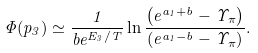Convert formula to latex. <formula><loc_0><loc_0><loc_500><loc_500>\Phi ( p _ { 3 } ) \simeq \frac { 1 } { b e ^ { E _ { 3 } / T } } \ln \frac { \left ( e ^ { a _ { 1 } + b } - \Upsilon _ { \pi } \right ) } { \left ( e ^ { a _ { 1 } - b } - \Upsilon _ { \pi } \right ) } .</formula> 